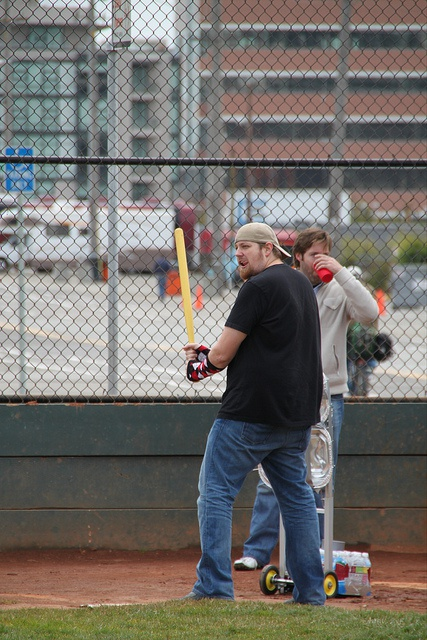Describe the objects in this image and their specific colors. I can see people in brown, black, navy, blue, and gray tones, people in brown, darkgray, gray, and darkblue tones, truck in brown, lightgray, gray, and darkgray tones, baseball bat in brown, khaki, and tan tones, and bottle in brown, darkgray, gray, and lightgray tones in this image. 